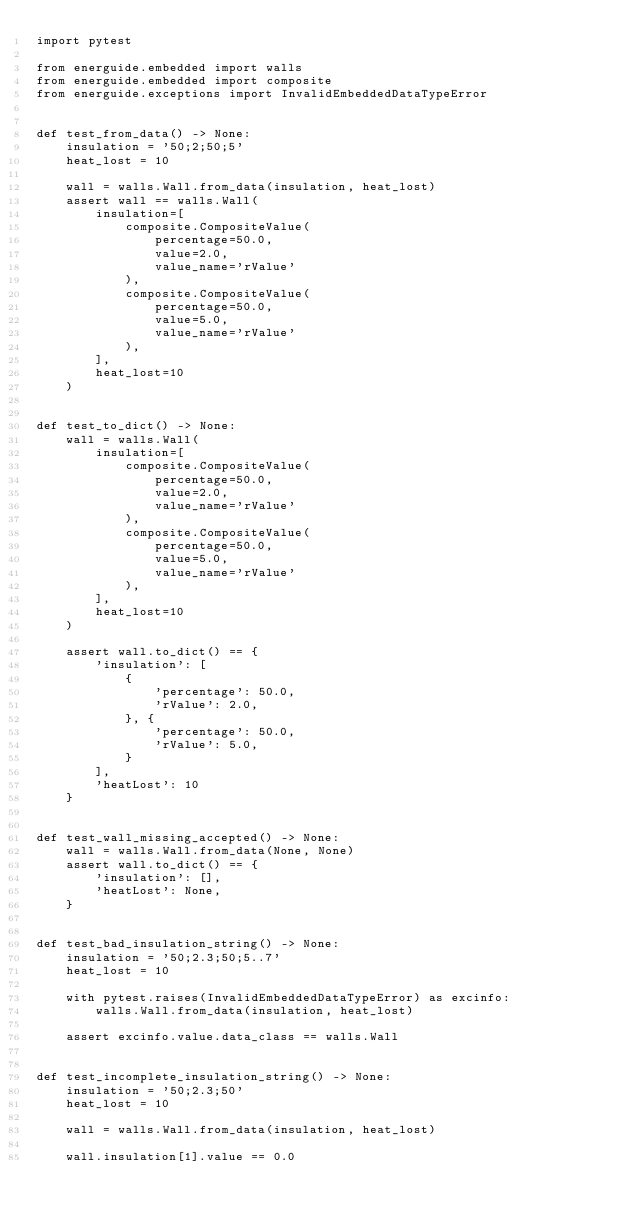<code> <loc_0><loc_0><loc_500><loc_500><_Python_>import pytest

from energuide.embedded import walls
from energuide.embedded import composite
from energuide.exceptions import InvalidEmbeddedDataTypeError


def test_from_data() -> None:
    insulation = '50;2;50;5'
    heat_lost = 10

    wall = walls.Wall.from_data(insulation, heat_lost)
    assert wall == walls.Wall(
        insulation=[
            composite.CompositeValue(
                percentage=50.0,
                value=2.0,
                value_name='rValue'
            ),
            composite.CompositeValue(
                percentage=50.0,
                value=5.0,
                value_name='rValue'
            ),
        ],
        heat_lost=10
    )


def test_to_dict() -> None:
    wall = walls.Wall(
        insulation=[
            composite.CompositeValue(
                percentage=50.0,
                value=2.0,
                value_name='rValue'
            ),
            composite.CompositeValue(
                percentage=50.0,
                value=5.0,
                value_name='rValue'
            ),
        ],
        heat_lost=10
    )

    assert wall.to_dict() == {
        'insulation': [
            {
                'percentage': 50.0,
                'rValue': 2.0,
            }, {
                'percentage': 50.0,
                'rValue': 5.0,
            }
        ],
        'heatLost': 10
    }


def test_wall_missing_accepted() -> None:
    wall = walls.Wall.from_data(None, None)
    assert wall.to_dict() == {
        'insulation': [],
        'heatLost': None,
    }


def test_bad_insulation_string() -> None:
    insulation = '50;2.3;50;5..7'
    heat_lost = 10

    with pytest.raises(InvalidEmbeddedDataTypeError) as excinfo:
        walls.Wall.from_data(insulation, heat_lost)

    assert excinfo.value.data_class == walls.Wall


def test_incomplete_insulation_string() -> None:
    insulation = '50;2.3;50'
    heat_lost = 10

    wall = walls.Wall.from_data(insulation, heat_lost)

    wall.insulation[1].value == 0.0
</code> 